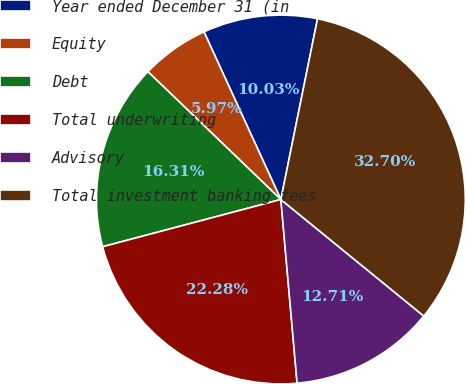Convert chart. <chart><loc_0><loc_0><loc_500><loc_500><pie_chart><fcel>Year ended December 31 (in<fcel>Equity<fcel>Debt<fcel>Total underwriting<fcel>Advisory<fcel>Total investment banking fees<nl><fcel>10.03%<fcel>5.97%<fcel>16.31%<fcel>22.28%<fcel>12.71%<fcel>32.7%<nl></chart> 